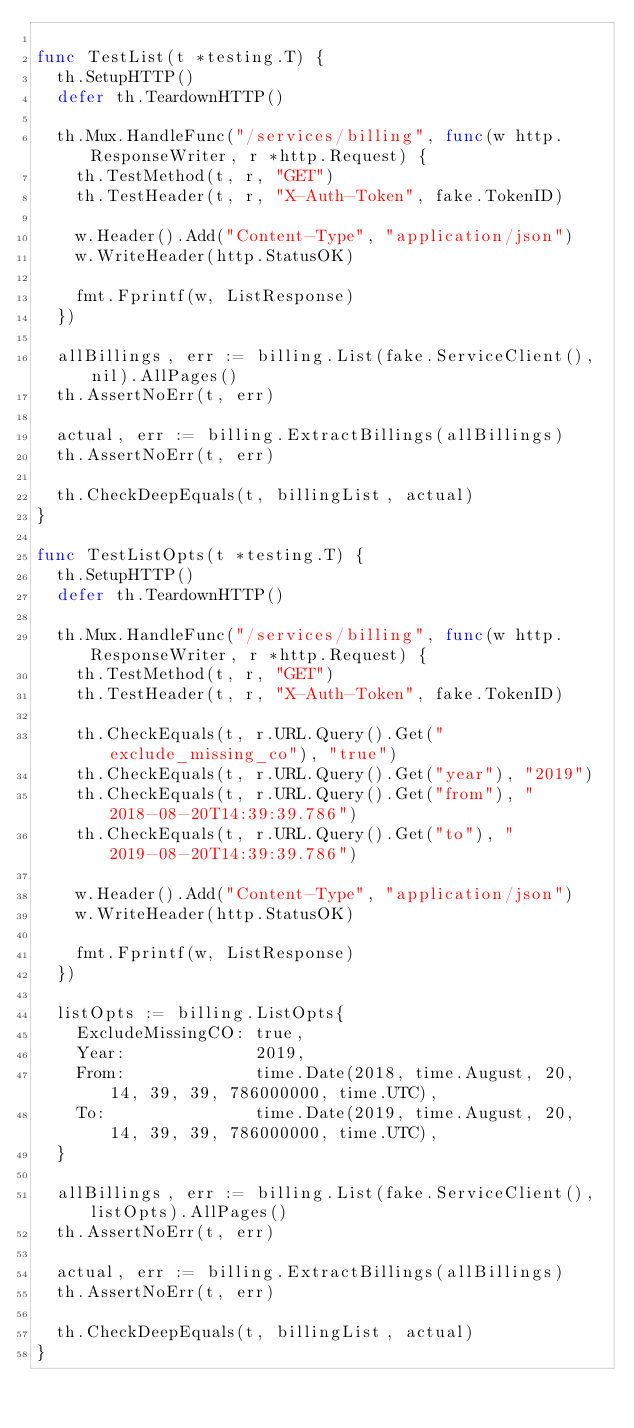Convert code to text. <code><loc_0><loc_0><loc_500><loc_500><_Go_>
func TestList(t *testing.T) {
	th.SetupHTTP()
	defer th.TeardownHTTP()

	th.Mux.HandleFunc("/services/billing", func(w http.ResponseWriter, r *http.Request) {
		th.TestMethod(t, r, "GET")
		th.TestHeader(t, r, "X-Auth-Token", fake.TokenID)

		w.Header().Add("Content-Type", "application/json")
		w.WriteHeader(http.StatusOK)

		fmt.Fprintf(w, ListResponse)
	})

	allBillings, err := billing.List(fake.ServiceClient(), nil).AllPages()
	th.AssertNoErr(t, err)

	actual, err := billing.ExtractBillings(allBillings)
	th.AssertNoErr(t, err)

	th.CheckDeepEquals(t, billingList, actual)
}

func TestListOpts(t *testing.T) {
	th.SetupHTTP()
	defer th.TeardownHTTP()

	th.Mux.HandleFunc("/services/billing", func(w http.ResponseWriter, r *http.Request) {
		th.TestMethod(t, r, "GET")
		th.TestHeader(t, r, "X-Auth-Token", fake.TokenID)

		th.CheckEquals(t, r.URL.Query().Get("exclude_missing_co"), "true")
		th.CheckEquals(t, r.URL.Query().Get("year"), "2019")
		th.CheckEquals(t, r.URL.Query().Get("from"), "2018-08-20T14:39:39.786")
		th.CheckEquals(t, r.URL.Query().Get("to"), "2019-08-20T14:39:39.786")

		w.Header().Add("Content-Type", "application/json")
		w.WriteHeader(http.StatusOK)

		fmt.Fprintf(w, ListResponse)
	})

	listOpts := billing.ListOpts{
		ExcludeMissingCO: true,
		Year:             2019,
		From:             time.Date(2018, time.August, 20, 14, 39, 39, 786000000, time.UTC),
		To:               time.Date(2019, time.August, 20, 14, 39, 39, 786000000, time.UTC),
	}

	allBillings, err := billing.List(fake.ServiceClient(), listOpts).AllPages()
	th.AssertNoErr(t, err)

	actual, err := billing.ExtractBillings(allBillings)
	th.AssertNoErr(t, err)

	th.CheckDeepEquals(t, billingList, actual)
}
</code> 